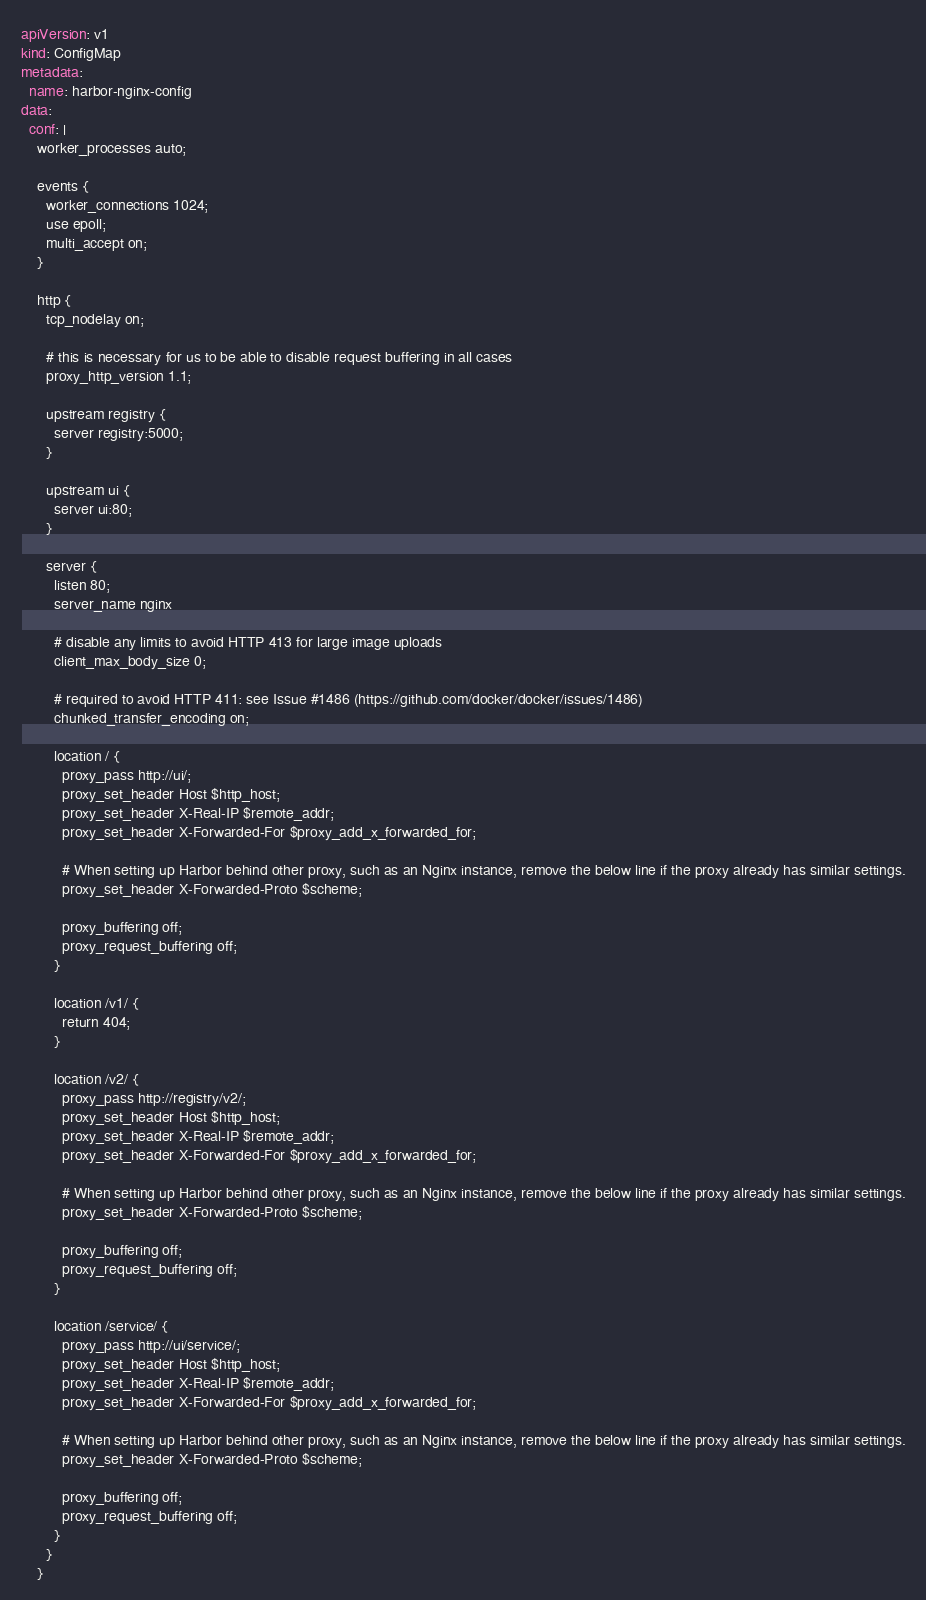<code> <loc_0><loc_0><loc_500><loc_500><_YAML_>apiVersion: v1
kind: ConfigMap
metadata:
  name: harbor-nginx-config
data:
  conf: |
    worker_processes auto;

    events {
      worker_connections 1024;
      use epoll;
      multi_accept on;
    }

    http {
      tcp_nodelay on;

      # this is necessary for us to be able to disable request buffering in all cases
      proxy_http_version 1.1;

      upstream registry {
        server registry:5000;
      }

      upstream ui {
        server ui:80;
      }

      server {
        listen 80;
        server_name nginx 

        # disable any limits to avoid HTTP 413 for large image uploads
        client_max_body_size 0;

        # required to avoid HTTP 411: see Issue #1486 (https://github.com/docker/docker/issues/1486)
        chunked_transfer_encoding on;

        location / {
          proxy_pass http://ui/;
          proxy_set_header Host $http_host;
          proxy_set_header X-Real-IP $remote_addr;
          proxy_set_header X-Forwarded-For $proxy_add_x_forwarded_for;

          # When setting up Harbor behind other proxy, such as an Nginx instance, remove the below line if the proxy already has similar settings.
          proxy_set_header X-Forwarded-Proto $scheme;
        
          proxy_buffering off;
          proxy_request_buffering off;
        }

        location /v1/ {
          return 404;
        }

        location /v2/ {
          proxy_pass http://registry/v2/;
          proxy_set_header Host $http_host;
          proxy_set_header X-Real-IP $remote_addr;
          proxy_set_header X-Forwarded-For $proxy_add_x_forwarded_for;

          # When setting up Harbor behind other proxy, such as an Nginx instance, remove the below line if the proxy already has similar settings.
          proxy_set_header X-Forwarded-Proto $scheme;

          proxy_buffering off;
          proxy_request_buffering off;
        }

        location /service/ {
          proxy_pass http://ui/service/;
          proxy_set_header Host $http_host;
          proxy_set_header X-Real-IP $remote_addr;
          proxy_set_header X-Forwarded-For $proxy_add_x_forwarded_for;
        
          # When setting up Harbor behind other proxy, such as an Nginx instance, remove the below line if the proxy already has similar settings.
          proxy_set_header X-Forwarded-Proto $scheme;
        
          proxy_buffering off;
          proxy_request_buffering off;
        }
      }
    }
</code> 